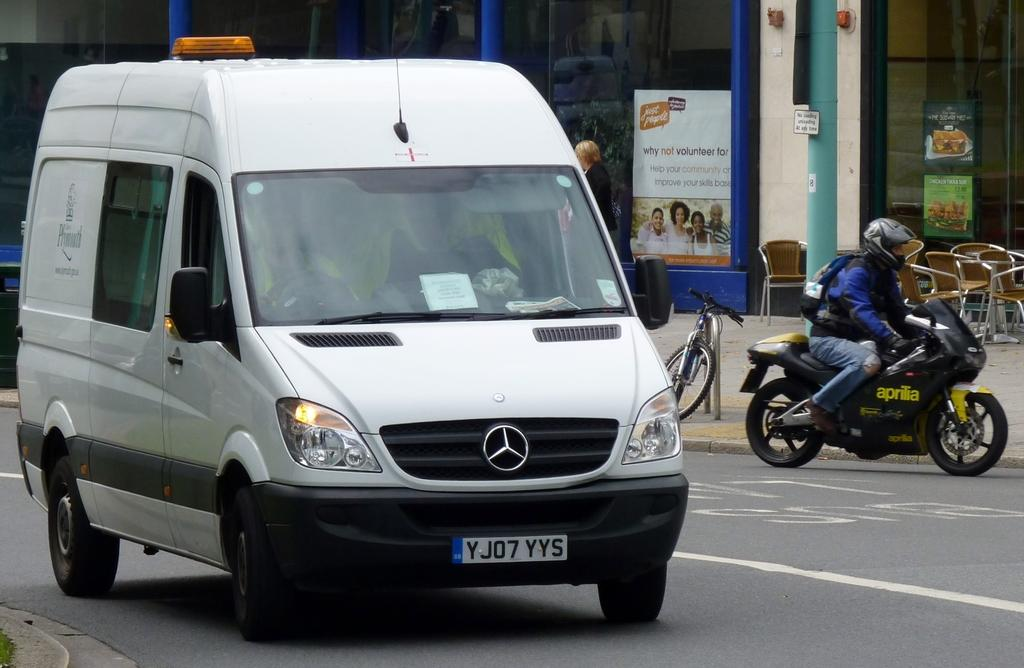<image>
Summarize the visual content of the image. A Mercedes van with license plate YJ07YYS drives down the street. 